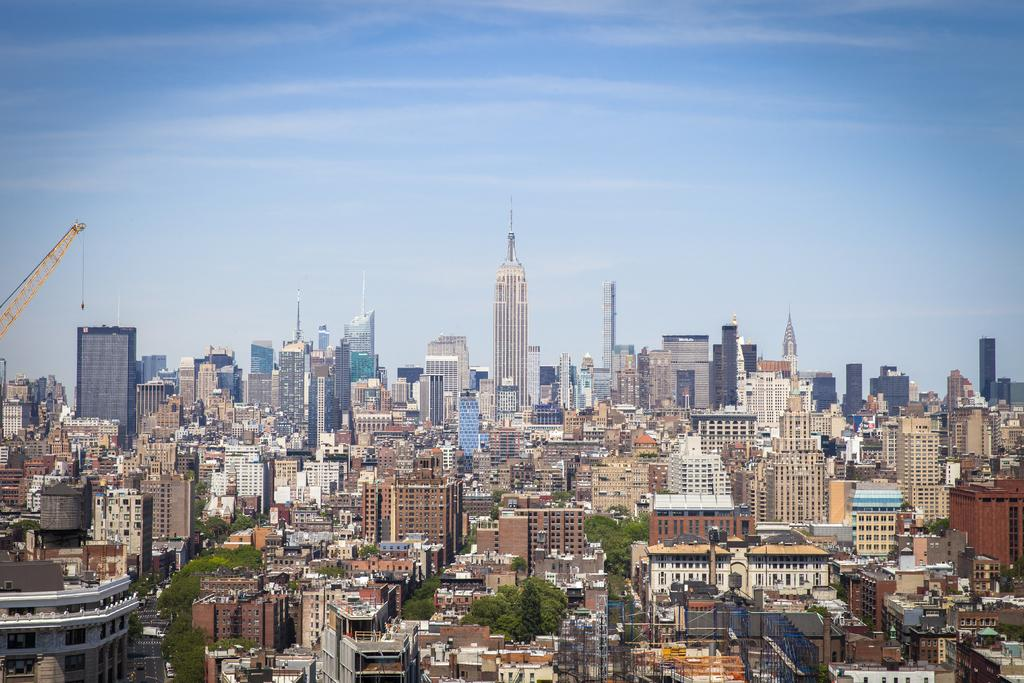What type of structures can be seen in the image? There are buildings in the image. What other natural elements are present in the image? There are trees in the image. What type of machinery is visible in the image? There is a crane in the image. What can be seen in the distance in the image? The sky is visible in the background of the image. What type of jam is being spread on the circle in the image? There is no circle or jam present in the image. 